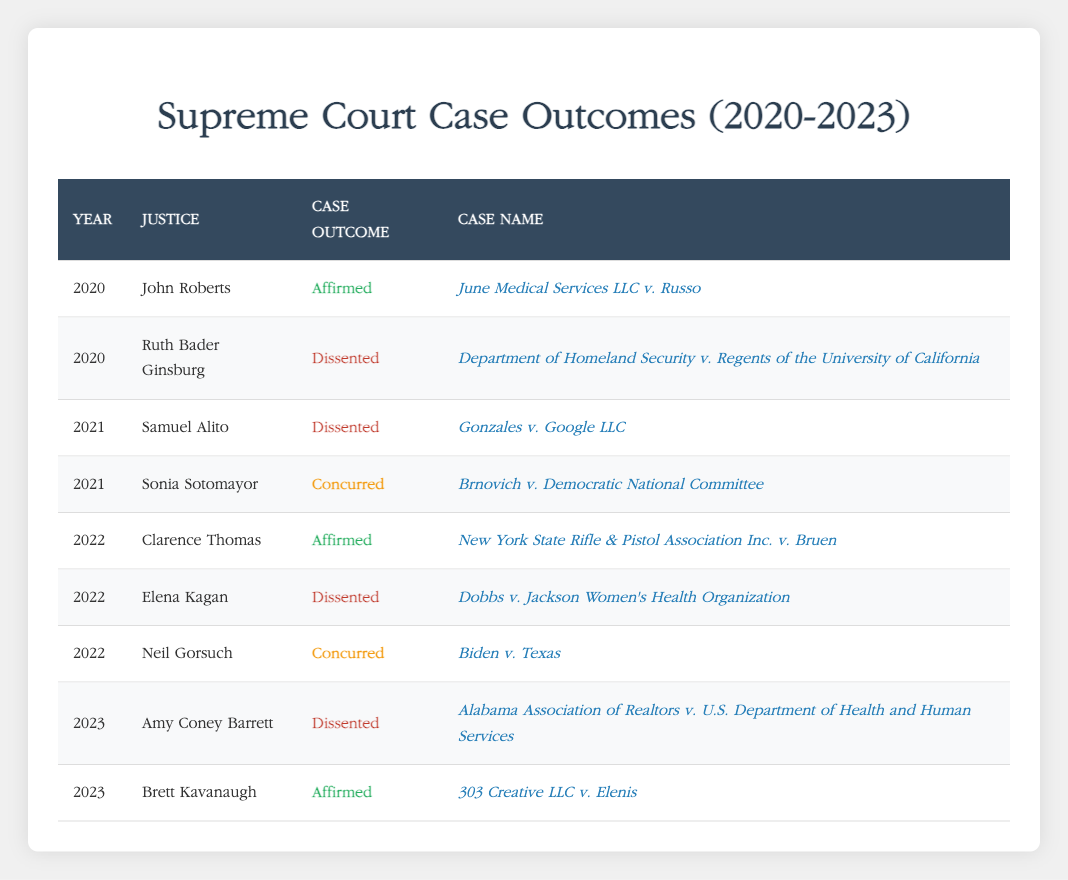What case did John Roberts affirm in 2020? The table shows that John Roberts affirmed the case named "June Medical Services LLC v. Russo" in the year 2020. This information can be found in the entry for 2020 under his name in the 'Case Name' column.
Answer: June Medical Services LLC v. Russo How many justices dissented in cases during 2022? In 2022, two justices dissented: Elena Kagan and Samuel Alito. This can be identified by looking for rows from the year 2022 that list the Case Outcome as "Dissented." There are two entries: one for Elena Kagan and one for Samuel Alito.
Answer: 2 Which justice affirmed cases in both 2020 and 2022? The table shows that John Roberts affirmed a case in 2020 and Clarence Thomas affirmed a case in 2022. However, focusing on just one justice, only Clarence Thomas affirmed a case in 2022, so John Roberts is the only one who has affirmed in both years.
Answer: John Roberts In which year did Sonia Sotomayor concur in a case? Looking at the table, Sonia Sotomayor concurred in the case "Brnovich v. Democratic National Committee," which occurred in 2021. This can be seen by checking the row associated with her name.
Answer: 2021 Is it true that Ruth Bader Ginsburg dissented in 2021? The table indicates that Ruth Bader Ginsburg dissented in 2020, not in 2021. Therefore, the correct answer is no, she did not dissent in 2021.
Answer: No Which case had the most recent affirmed outcome and who was the justice? The most recent affirmed outcome listed in the table is "303 Creative LLC v. Elenis," affirmed by Brett Kavanaugh in 2023. This can be found by looking at the rows for 2023 and recognizing the outcome for the case assigned to Brett Kavanaugh.
Answer: 303 Creative LLC v. Elenis, Brett Kavanaugh How many cases were affirmed by justices in 2022? In 2022, there were two cases affirmed by justices: "New York State Rifle & Pistol Association Inc. v. Bruen" affirmed by Clarence Thomas and one more case that has the affirmed outcome can be confirmed by scanning through the 2022 entries. Since only one case was affirmed when confirming Clarence Thomas's entry.
Answer: 1 What was the outcome of the case "Dobbs v. Jackson Women's Health Organization"? The table specifies that the outcome of the case "Dobbs v. Jackson Women's Health Organization" was a dissent, as listed under Elena Kagan for the year 2022. By matching the case name with its corresponding row, the outcome can be identified.
Answer: Dissented 